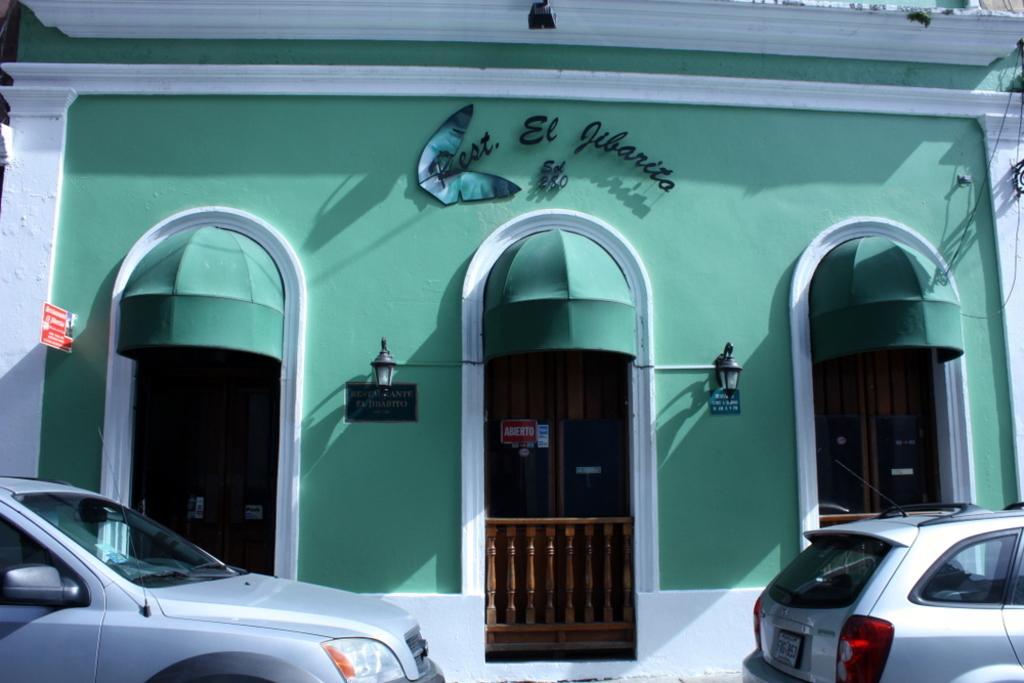Could you give a brief overview of what you see in this image? In this picture we can see vehicles, doors, name boards, lamps, building, fence and some objects. 